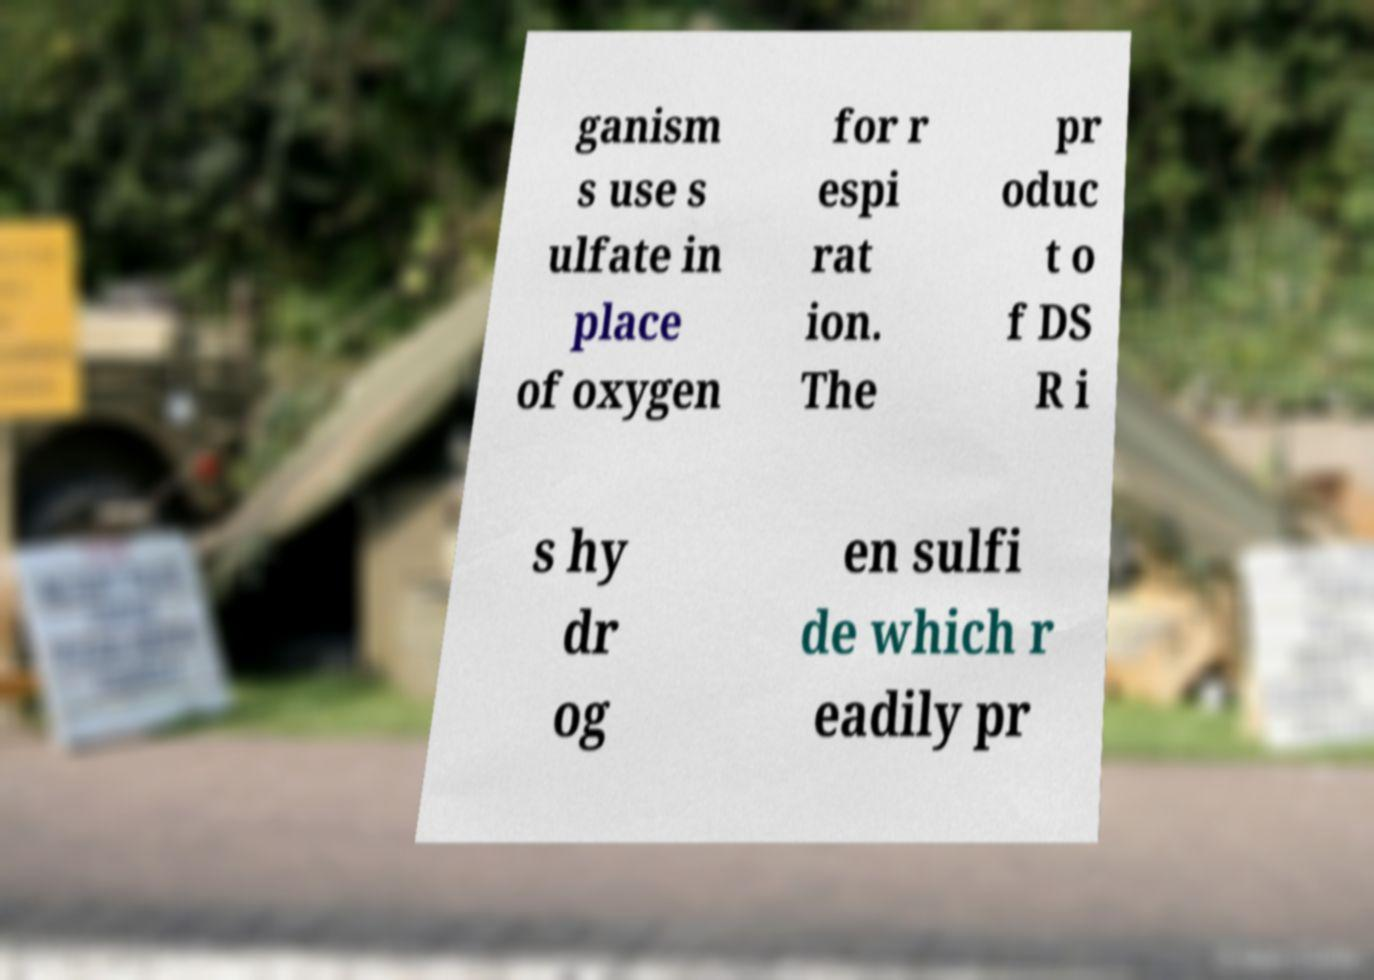Please read and relay the text visible in this image. What does it say? ganism s use s ulfate in place of oxygen for r espi rat ion. The pr oduc t o f DS R i s hy dr og en sulfi de which r eadily pr 